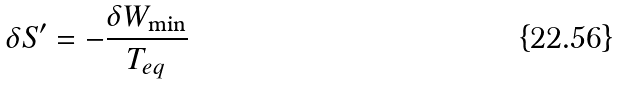<formula> <loc_0><loc_0><loc_500><loc_500>\delta S ^ { \prime } = - \frac { \delta W _ { \min } } { T _ { e q } }</formula> 